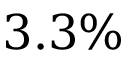<formula> <loc_0><loc_0><loc_500><loc_500>3 . 3 \%</formula> 